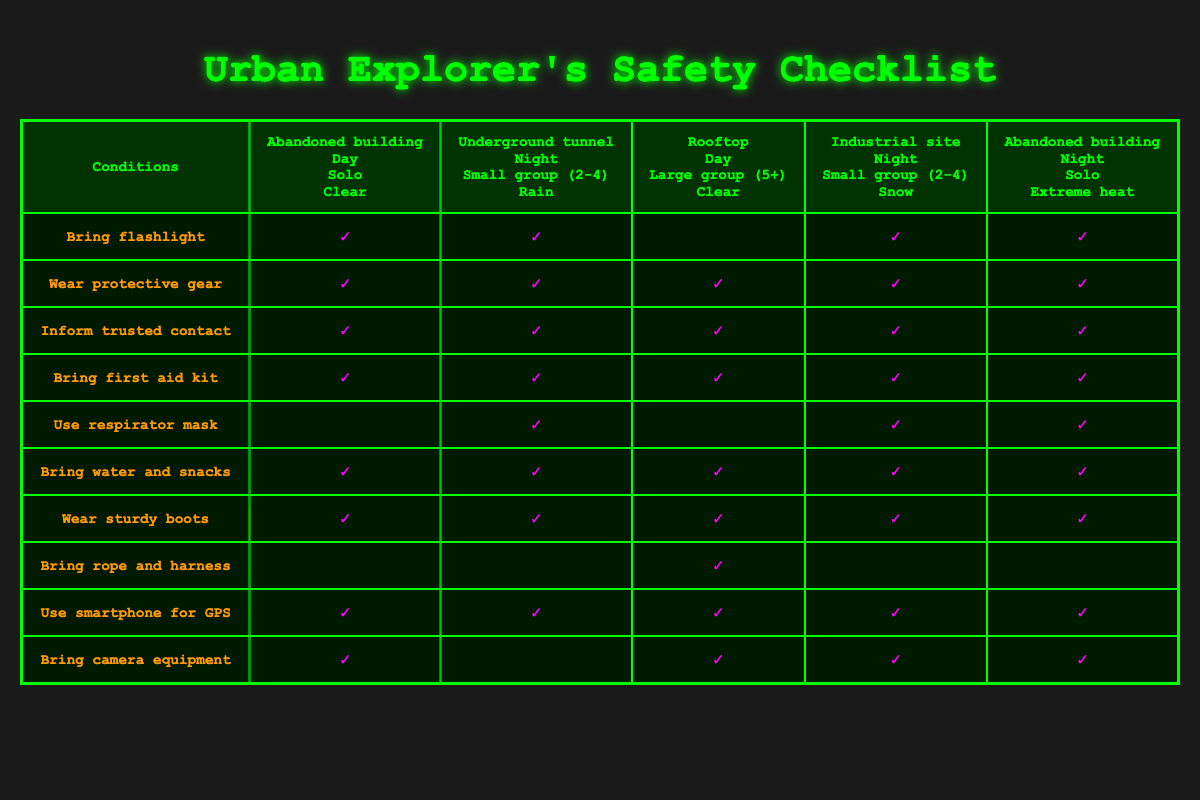What essential equipment should I bring when exploring an abandoned building during the day? Looking at the row for "Abandoned building, Day, Solo, Clear," the actions include "Bring flashlight," "Wear protective gear," "Inform trusted contact," "Bring first aid kit," "Bring water and snacks," "Wear sturdy boots," "Use smartphone for GPS," and "Bring camera equipment." These items ensure safety and preparedness during the exploration.
Answer: Bring flashlight, wear protective gear, inform trusted contact, bring first aid kit, bring water and snacks, wear sturdy boots, use smartphone for GPS, bring camera equipment Is wearing a respirator mask necessary while exploring an underground tunnel at night with a small group in the rain? Referring to the row for "Underground tunnel, Night, Small group (2-4), Rain," wearing a respirator mask is indeed indicated. This suggests that the air quality may be compromised, warranting extra protection.
Answer: Yes How many total actions are advised for exploring a rooftop during the day with a large group? For the row labeled "Rooftop, Day, Large group (5+), Clear," the actions listed are "Wear protective gear," "Inform trusted contact," "Bring first aid kit," "Bring water and snacks," "Wear sturdy boots," "Bring rope and harness," "Use smartphone for GPS," and "Bring camera equipment." This totals 8 actions to be taken into account.
Answer: 8 If I am exploring an industrial site at night with a small group in the snow, which checklist items are recommended? Looking at the row for "Industrial site, Night, Small group (2-4), Snow," the actions noted are "Bring flashlight," "Wear protective gear," "Inform trusted contact," "Bring first aid kit," "Use respirator mask," "Bring water and snacks," "Wear sturdy boots," "Use smartphone for GPS," and "Bring camera equipment." These items highlight the need for safety precautions due to the conditions of cold and darkness.
Answer: Bring flashlight, wear protective gear, inform trusted contact, bring first aid kit, use respirator mask, bring water and snacks, wear sturdy boots, use smartphone for GPS, bring camera equipment During what weather condition is it recommended to wear a respirator mask while exploring? The rows for "Underground tunnel, Night, Small group (2-4), Rain," "Industrial site, Night, Small group (2-4), Snow," and "Abandoned building, Night, Solo, Extreme heat" indicate the requirement for a respirator mask, suggesting that adverse weather conditions such as rain, snow, and extreme heat can necessitate its use for safety reasons.
Answer: Rain, snow, extreme heat 